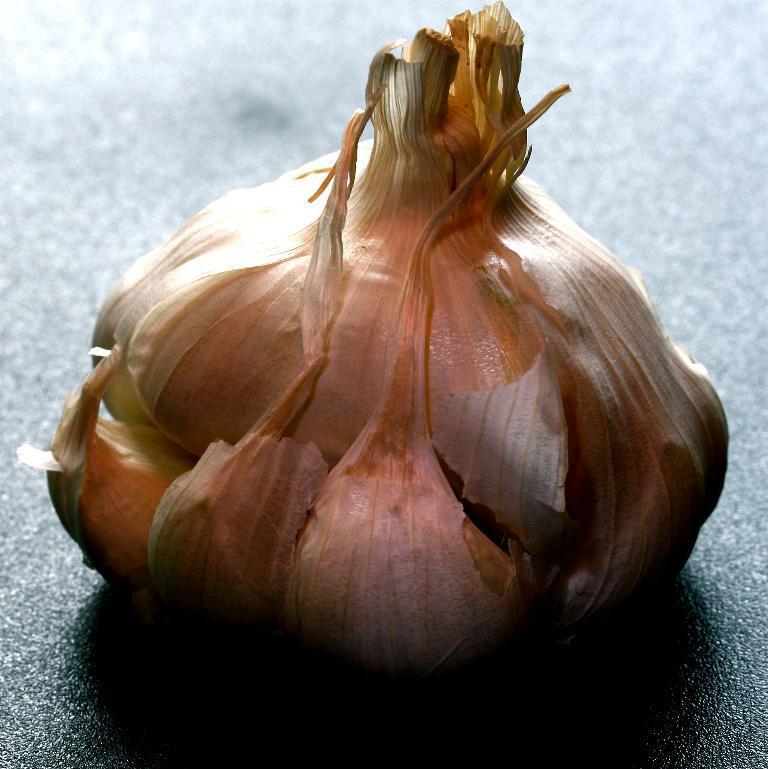Can you describe this image briefly? In this image we can see a garlic placed on the surface. 